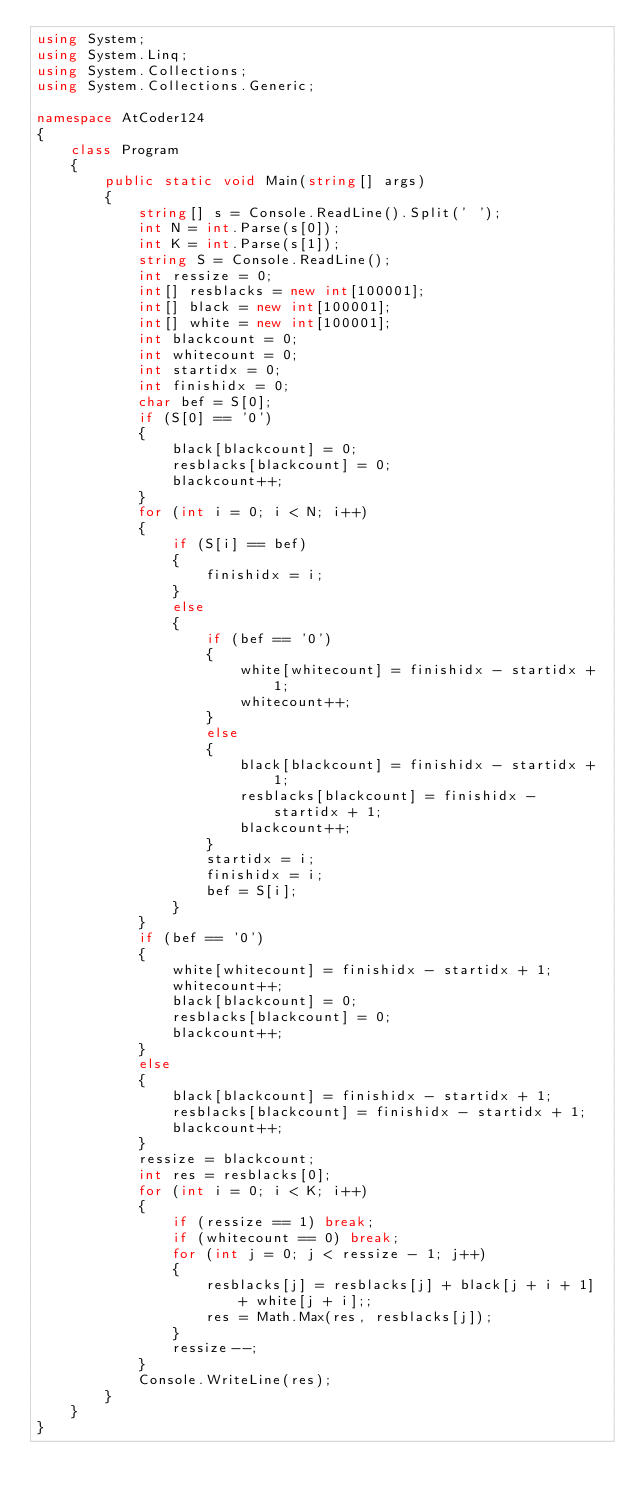Convert code to text. <code><loc_0><loc_0><loc_500><loc_500><_C#_>using System;
using System.Linq;
using System.Collections;
using System.Collections.Generic;

namespace AtCoder124
{
    class Program
    {
        public static void Main(string[] args)
        {
            string[] s = Console.ReadLine().Split(' ');
            int N = int.Parse(s[0]);
            int K = int.Parse(s[1]);
            string S = Console.ReadLine();
            int ressize = 0;
            int[] resblacks = new int[100001];
            int[] black = new int[100001];
            int[] white = new int[100001];
            int blackcount = 0;
            int whitecount = 0;
            int startidx = 0;
            int finishidx = 0;
            char bef = S[0];
            if (S[0] == '0')
            {
                black[blackcount] = 0;
                resblacks[blackcount] = 0;
                blackcount++;
            }
            for (int i = 0; i < N; i++)
            {
                if (S[i] == bef)
                {
                    finishidx = i;
                }
                else
                {
                    if (bef == '0')
                    {
                        white[whitecount] = finishidx - startidx + 1;
                        whitecount++;
                    }
                    else
                    {
                        black[blackcount] = finishidx - startidx + 1;
                        resblacks[blackcount] = finishidx - startidx + 1;
                        blackcount++;
                    }
                    startidx = i;
                    finishidx = i;
                    bef = S[i];
                }
            }
            if (bef == '0')
            {
                white[whitecount] = finishidx - startidx + 1;
                whitecount++;
                black[blackcount] = 0;
                resblacks[blackcount] = 0;
                blackcount++;
            }
            else
            {
                black[blackcount] = finishidx - startidx + 1;
                resblacks[blackcount] = finishidx - startidx + 1;
                blackcount++;
            }
            ressize = blackcount;
            int res = resblacks[0];
            for (int i = 0; i < K; i++)
            {
                if (ressize == 1) break;
                if (whitecount == 0) break;
                for (int j = 0; j < ressize - 1; j++)
                {
                    resblacks[j] = resblacks[j] + black[j + i + 1] + white[j + i];;
                    res = Math.Max(res, resblacks[j]);
                }
                ressize--;
            }
            Console.WriteLine(res);
        }
    }
}</code> 